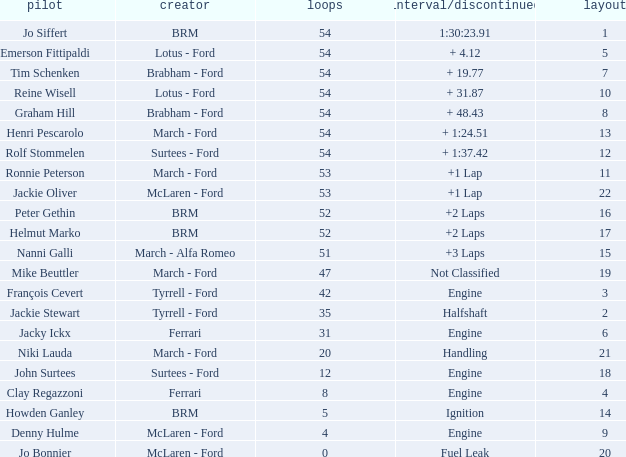What is the average grid that has over 8 laps, a Time/Retired of +2 laps, and peter gethin driving? 16.0. Can you give me this table as a dict? {'header': ['pilot', 'creator', 'loops', 'interval/discontinued', 'layout'], 'rows': [['Jo Siffert', 'BRM', '54', '1:30:23.91', '1'], ['Emerson Fittipaldi', 'Lotus - Ford', '54', '+ 4.12', '5'], ['Tim Schenken', 'Brabham - Ford', '54', '+ 19.77', '7'], ['Reine Wisell', 'Lotus - Ford', '54', '+ 31.87', '10'], ['Graham Hill', 'Brabham - Ford', '54', '+ 48.43', '8'], ['Henri Pescarolo', 'March - Ford', '54', '+ 1:24.51', '13'], ['Rolf Stommelen', 'Surtees - Ford', '54', '+ 1:37.42', '12'], ['Ronnie Peterson', 'March - Ford', '53', '+1 Lap', '11'], ['Jackie Oliver', 'McLaren - Ford', '53', '+1 Lap', '22'], ['Peter Gethin', 'BRM', '52', '+2 Laps', '16'], ['Helmut Marko', 'BRM', '52', '+2 Laps', '17'], ['Nanni Galli', 'March - Alfa Romeo', '51', '+3 Laps', '15'], ['Mike Beuttler', 'March - Ford', '47', 'Not Classified', '19'], ['François Cevert', 'Tyrrell - Ford', '42', 'Engine', '3'], ['Jackie Stewart', 'Tyrrell - Ford', '35', 'Halfshaft', '2'], ['Jacky Ickx', 'Ferrari', '31', 'Engine', '6'], ['Niki Lauda', 'March - Ford', '20', 'Handling', '21'], ['John Surtees', 'Surtees - Ford', '12', 'Engine', '18'], ['Clay Regazzoni', 'Ferrari', '8', 'Engine', '4'], ['Howden Ganley', 'BRM', '5', 'Ignition', '14'], ['Denny Hulme', 'McLaren - Ford', '4', 'Engine', '9'], ['Jo Bonnier', 'McLaren - Ford', '0', 'Fuel Leak', '20']]} 